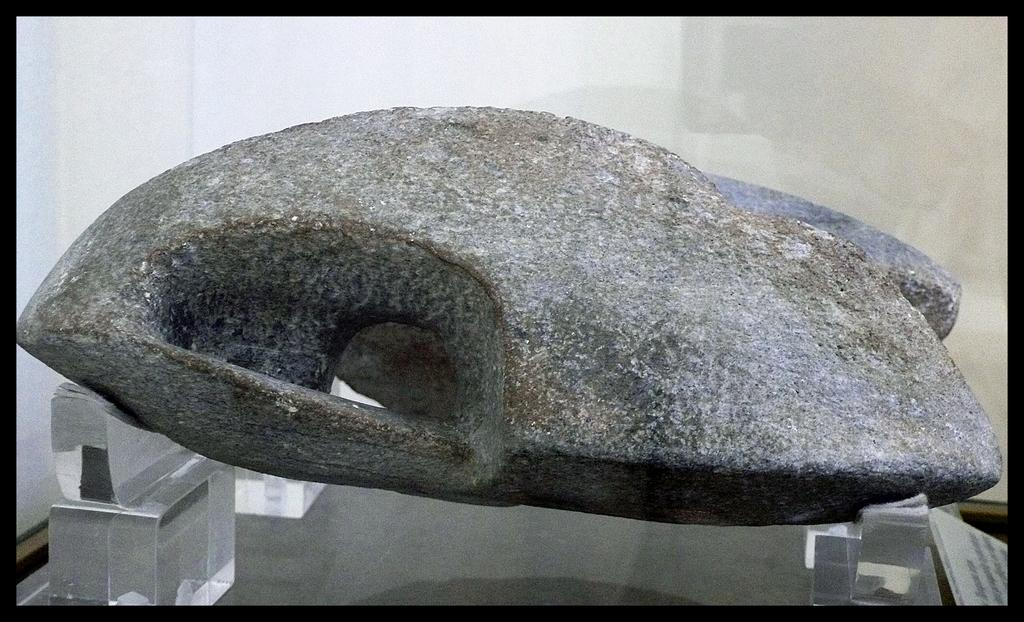What is the main object in the image? There is a stone in the image. What other objects can be seen in the image? There are glass objects in the image. How are the stone and glass objects related in the image? The stone is on the glass objects. What is visible behind the stone in the image? There is a wall behind the stone. Can you see the ocean in the image? No, the ocean is not visible in the image. What type of cast is being used on the stone in the image? There is no cast being used on the stone in the image. 